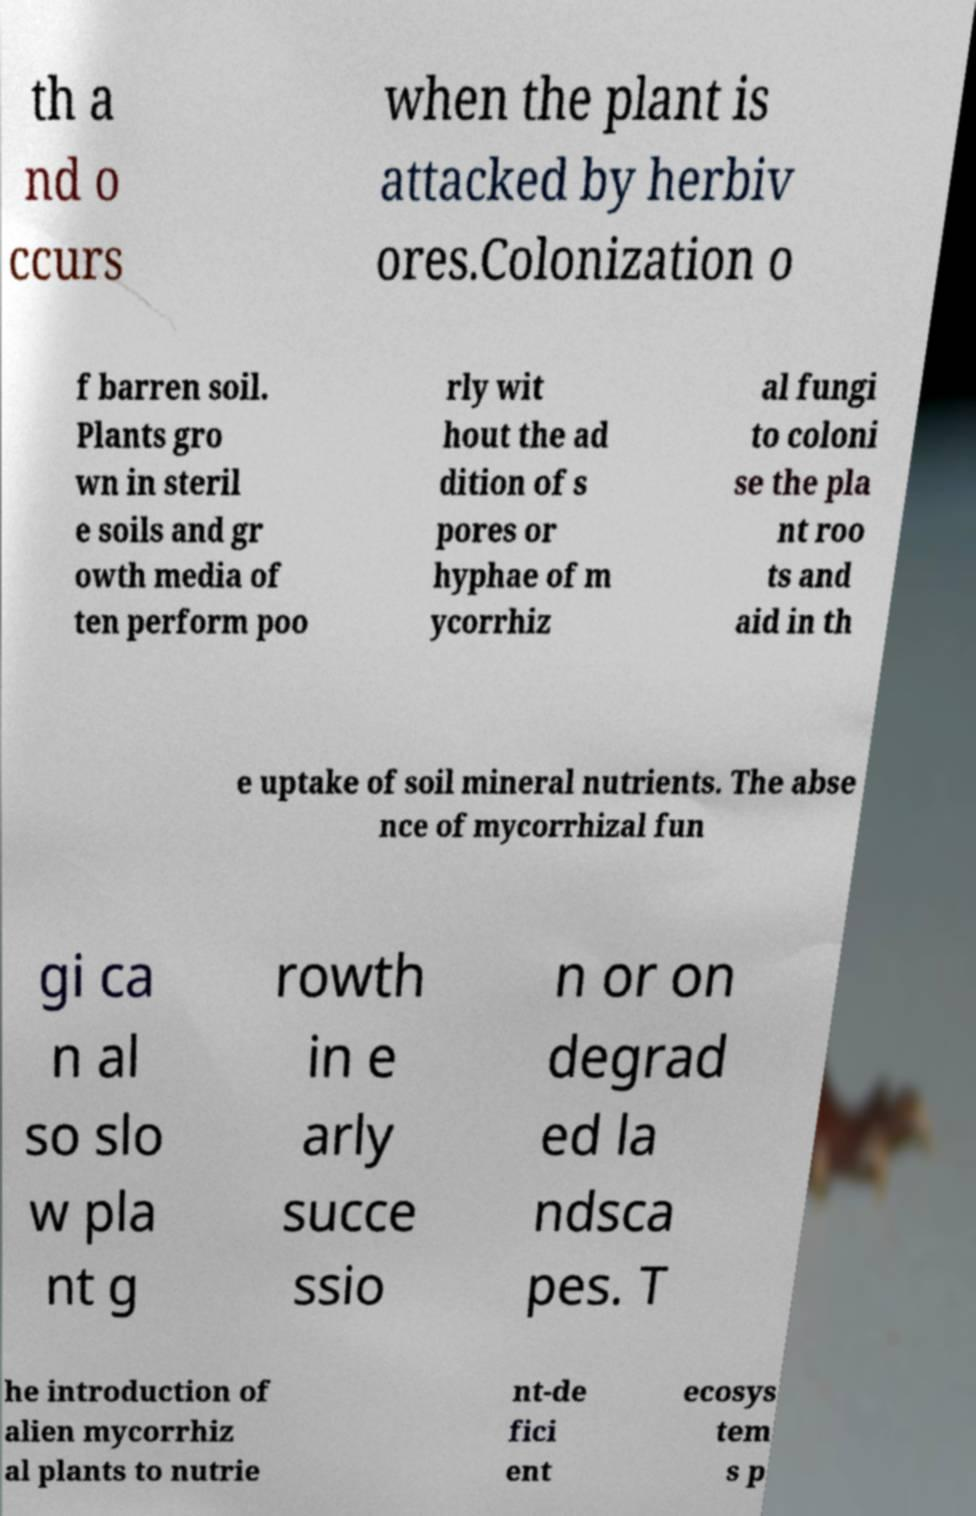Can you accurately transcribe the text from the provided image for me? th a nd o ccurs when the plant is attacked by herbiv ores.Colonization o f barren soil. Plants gro wn in steril e soils and gr owth media of ten perform poo rly wit hout the ad dition of s pores or hyphae of m ycorrhiz al fungi to coloni se the pla nt roo ts and aid in th e uptake of soil mineral nutrients. The abse nce of mycorrhizal fun gi ca n al so slo w pla nt g rowth in e arly succe ssio n or on degrad ed la ndsca pes. T he introduction of alien mycorrhiz al plants to nutrie nt-de fici ent ecosys tem s p 